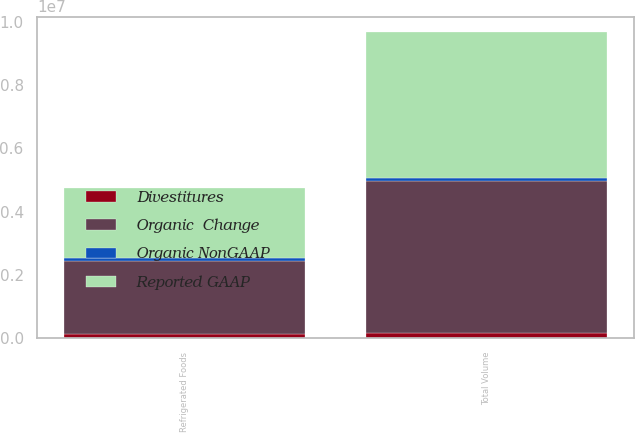Convert chart. <chart><loc_0><loc_0><loc_500><loc_500><stacked_bar_chart><ecel><fcel>Refrigerated Foods<fcel>Total Volume<nl><fcel>Organic  Change<fcel>2.32714e+06<fcel>4.79818e+06<nl><fcel>Divestitures<fcel>130301<fcel>176008<nl><fcel>Reported GAAP<fcel>2.19684e+06<fcel>4.62217e+06<nl><fcel>Organic NonGAAP<fcel>80454<fcel>80454<nl></chart> 